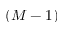Convert formula to latex. <formula><loc_0><loc_0><loc_500><loc_500>( M - 1 )</formula> 